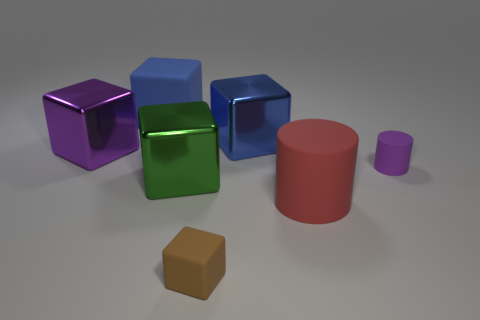Subtract 2 cubes. How many cubes are left? 3 Subtract all large blue metal cubes. How many cubes are left? 4 Subtract all purple cubes. How many cubes are left? 4 Subtract all yellow cubes. Subtract all cyan cylinders. How many cubes are left? 5 Add 2 small purple matte cylinders. How many objects exist? 9 Subtract all cylinders. How many objects are left? 5 Add 2 big things. How many big things exist? 7 Subtract 0 cyan blocks. How many objects are left? 7 Subtract all large rubber spheres. Subtract all large purple shiny things. How many objects are left? 6 Add 3 brown rubber blocks. How many brown rubber blocks are left? 4 